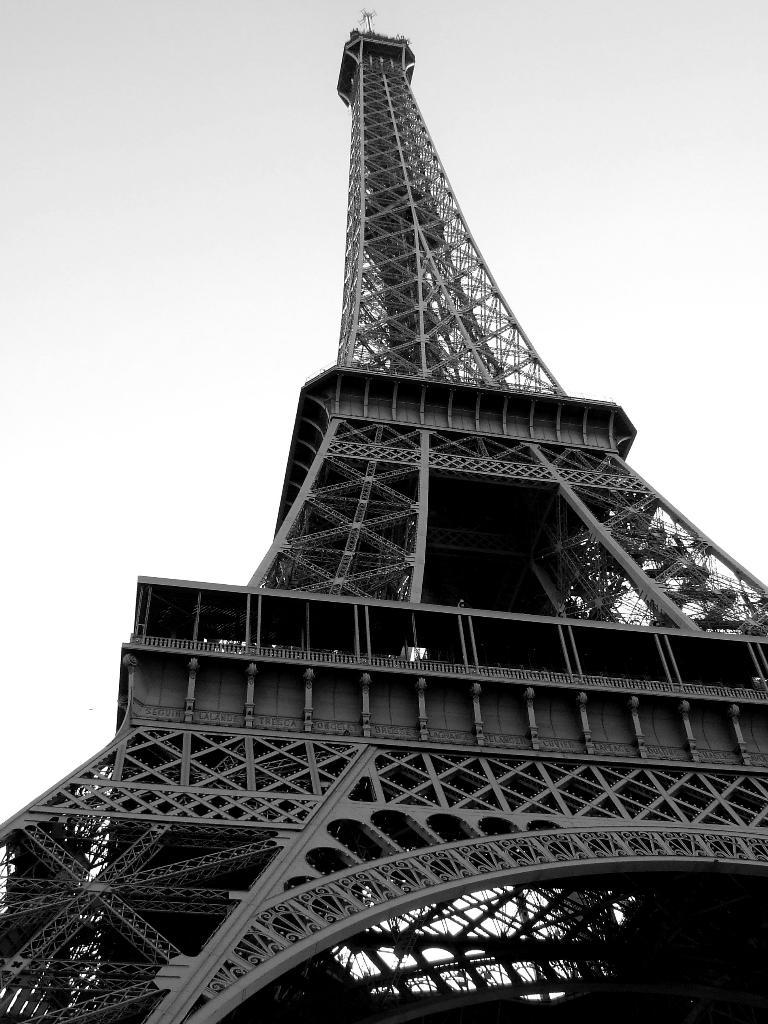What is the main subject in the middle of the image? The Eiffel tower is in the middle of the image. What can be seen at the top of the image? The sky is visible at the top of the image. How many books does the mother have in the image? There are no books or mothers present in the image; it features the Eiffel tower and the sky. What type of music is playing in the background of the image? There is no music present in the image; it only features the Eiffel tower and the sky. 